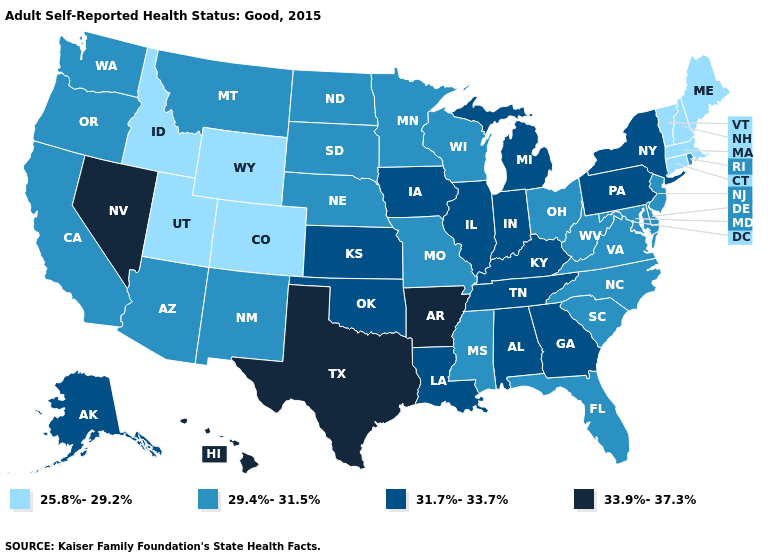Among the states that border South Dakota , does Wyoming have the lowest value?
Be succinct. Yes. Name the states that have a value in the range 25.8%-29.2%?
Be succinct. Colorado, Connecticut, Idaho, Maine, Massachusetts, New Hampshire, Utah, Vermont, Wyoming. Does Montana have the same value as Pennsylvania?
Short answer required. No. What is the lowest value in the USA?
Be succinct. 25.8%-29.2%. Which states have the lowest value in the USA?
Keep it brief. Colorado, Connecticut, Idaho, Maine, Massachusetts, New Hampshire, Utah, Vermont, Wyoming. Does the map have missing data?
Short answer required. No. How many symbols are there in the legend?
Answer briefly. 4. Which states have the lowest value in the West?
Be succinct. Colorado, Idaho, Utah, Wyoming. What is the value of Missouri?
Keep it brief. 29.4%-31.5%. Is the legend a continuous bar?
Short answer required. No. Name the states that have a value in the range 31.7%-33.7%?
Concise answer only. Alabama, Alaska, Georgia, Illinois, Indiana, Iowa, Kansas, Kentucky, Louisiana, Michigan, New York, Oklahoma, Pennsylvania, Tennessee. Among the states that border Illinois , does Missouri have the lowest value?
Be succinct. Yes. Name the states that have a value in the range 33.9%-37.3%?
Short answer required. Arkansas, Hawaii, Nevada, Texas. What is the value of Ohio?
Answer briefly. 29.4%-31.5%. What is the highest value in the USA?
Concise answer only. 33.9%-37.3%. 